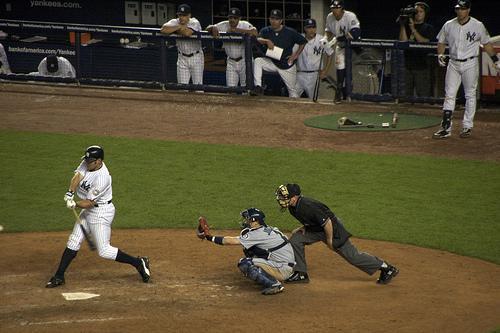How many women are pictured here?
Give a very brief answer. 0. How many people are there?
Give a very brief answer. 6. 